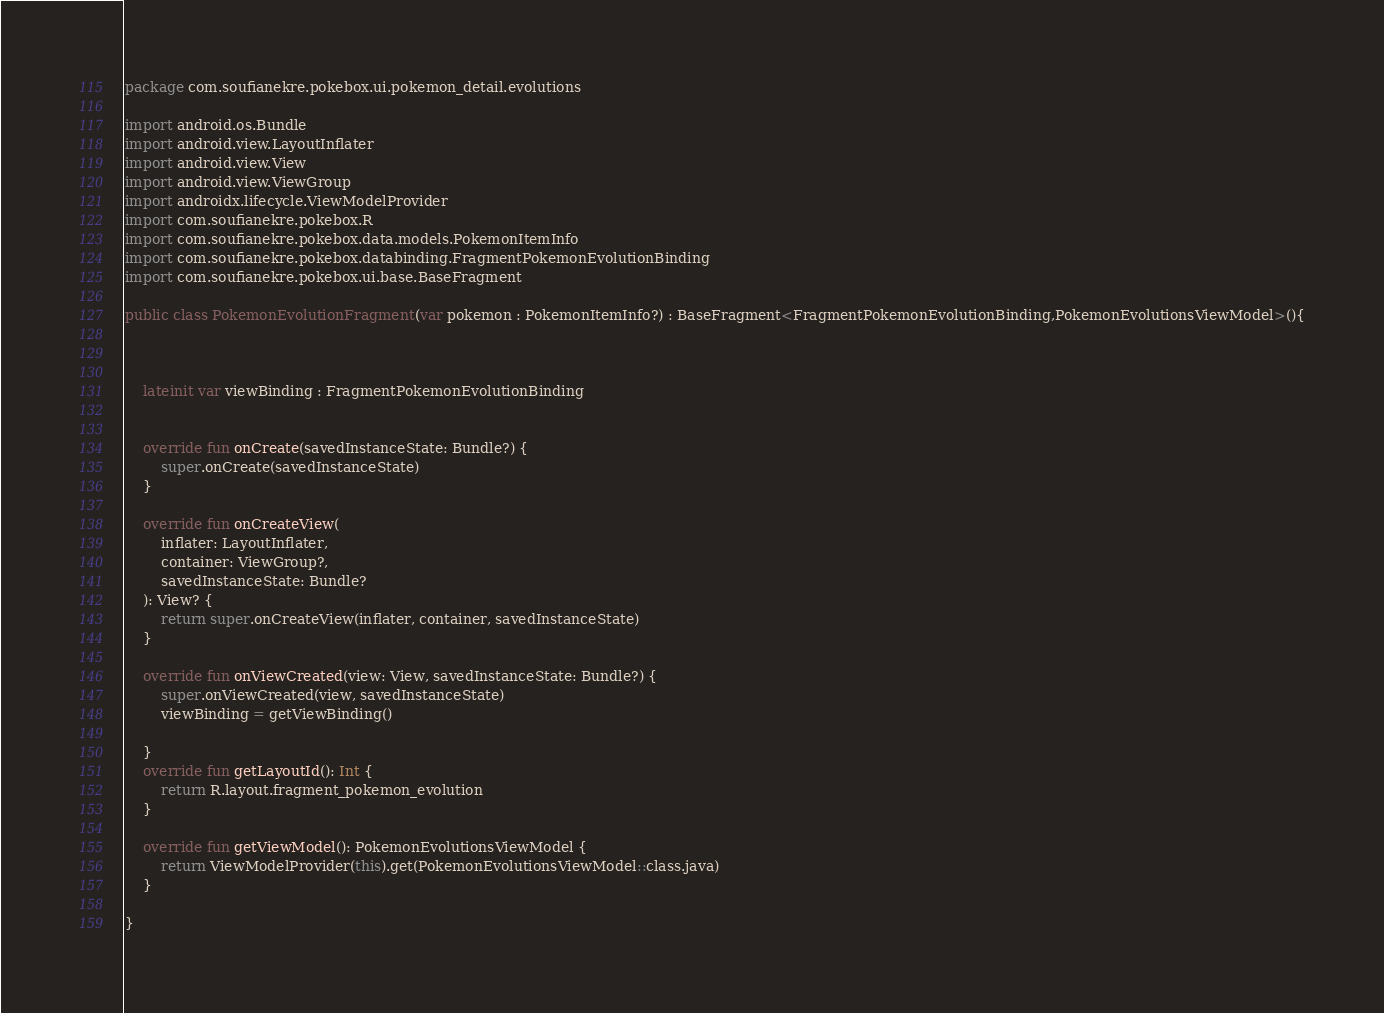<code> <loc_0><loc_0><loc_500><loc_500><_Kotlin_>package com.soufianekre.pokebox.ui.pokemon_detail.evolutions

import android.os.Bundle
import android.view.LayoutInflater
import android.view.View
import android.view.ViewGroup
import androidx.lifecycle.ViewModelProvider
import com.soufianekre.pokebox.R
import com.soufianekre.pokebox.data.models.PokemonItemInfo
import com.soufianekre.pokebox.databinding.FragmentPokemonEvolutionBinding
import com.soufianekre.pokebox.ui.base.BaseFragment

public class PokemonEvolutionFragment(var pokemon : PokemonItemInfo?) : BaseFragment<FragmentPokemonEvolutionBinding,PokemonEvolutionsViewModel>(){



    lateinit var viewBinding : FragmentPokemonEvolutionBinding


    override fun onCreate(savedInstanceState: Bundle?) {
        super.onCreate(savedInstanceState)
    }

    override fun onCreateView(
        inflater: LayoutInflater,
        container: ViewGroup?,
        savedInstanceState: Bundle?
    ): View? {
        return super.onCreateView(inflater, container, savedInstanceState)
    }

    override fun onViewCreated(view: View, savedInstanceState: Bundle?) {
        super.onViewCreated(view, savedInstanceState)
        viewBinding = getViewBinding()

    }
    override fun getLayoutId(): Int {
        return R.layout.fragment_pokemon_evolution
    }

    override fun getViewModel(): PokemonEvolutionsViewModel {
        return ViewModelProvider(this).get(PokemonEvolutionsViewModel::class.java)
    }

}</code> 